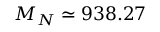<formula> <loc_0><loc_0><loc_500><loc_500>M _ { N } \simeq 9 3 8 . 2 7</formula> 